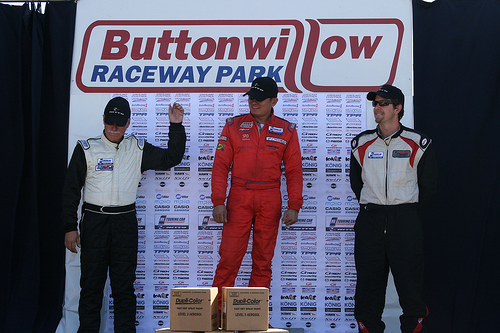<image>
Is the man above the box? No. The man is not positioned above the box. The vertical arrangement shows a different relationship. 